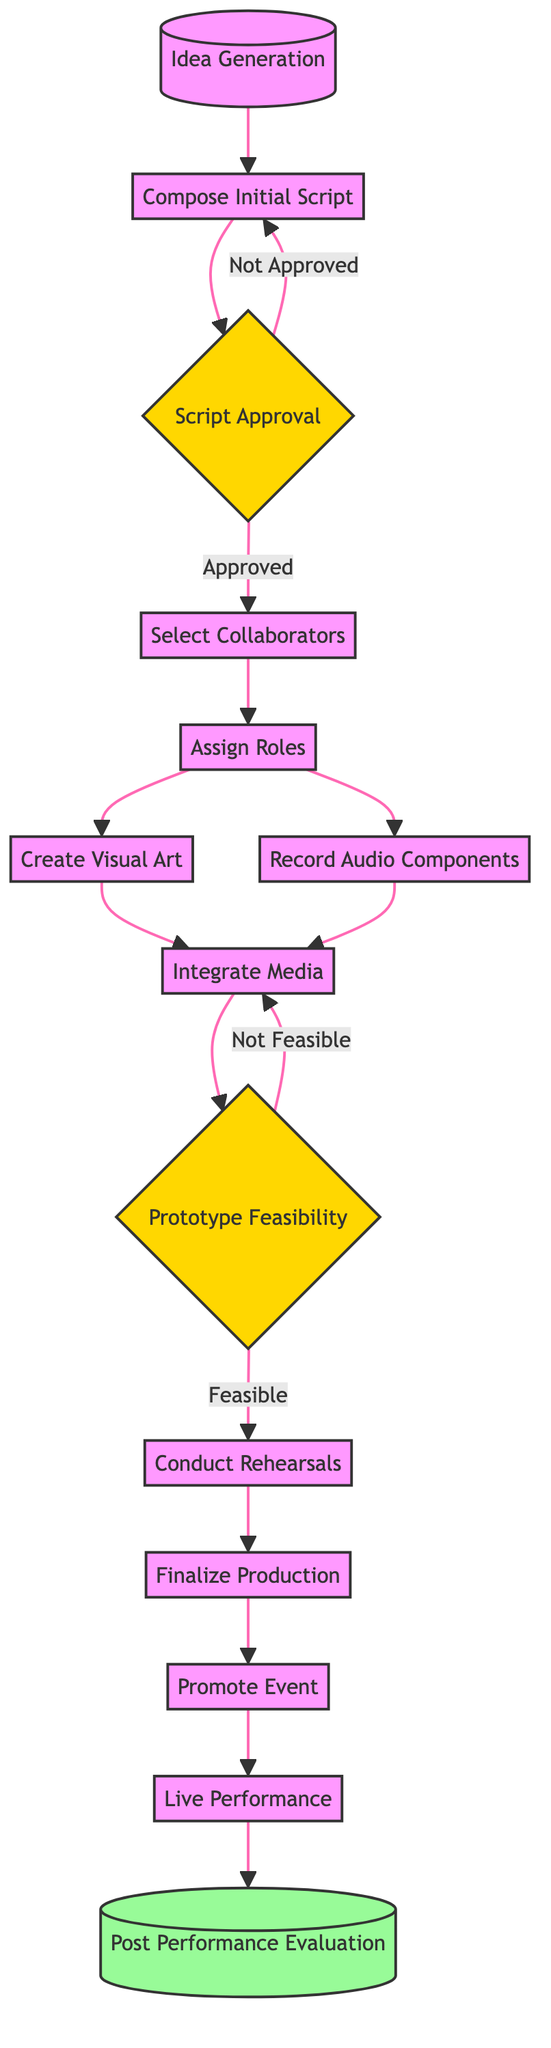What is the first activity in the diagram? The activity following the start event "IdeaGeneration" is "ComposeInitialScript." Since "IdeaGeneration" is the starting point, the next activity is clearly indicated as "ComposeInitialScript."
Answer: Compose Initial Script How many decision points are present in the diagram? There are two decision points labeled "ScriptApproval" and "PrototypeFeasibility." These decision nodes are where the flow can branch based on specific conditions.
Answer: 2 What activity follows "PromoteEvent"? The activity directly following "PromoteEvent" is "LivePerformance." This is evident as the arrow indicates flow routing from "PromoteEvent" to "LivePerformance."
Answer: Live Performance What happens if the initial script is not approved? If the initial script is not approved, the flow returns to the activity "ComposeInitialScript." This is illustrated by the arrow connecting the "Not Approved" path back to the "ComposeInitialScript" node.
Answer: Compose Initial Script Which activities require collaboration with an artist? The activities "CreateVisualArt" and "RecordAudioComponents" require collaboration with specific artists—visual and audio artists respectively, as indicated by the roles assigned during the "AssignRoles" step.
Answer: Create Visual Art, Record Audio Components What is the outcome if the prototype is deemed not feasible? If the prototype is not feasible, the flow loops back to "IntegrateMedia," allowing for further integration rather than proceeding to "ConductRehearsals." This connection is outlined in the transition labeled "Not Feasible."
Answer: Integrate Media How many activities are performed before the "LivePerformance"? There are six activities performed before reaching "LivePerformance": "ComposeInitialScript," "SelectCollaborators," "AssignRoles," "CreateVisualArt," "RecordAudioComponents," and "FinalizeProduction." Counting the activities in sequence leads us to this total.
Answer: 6 What is the last event in the diagram? The diagram concludes with the event "PostPerformanceEvaluation," which is indicated by the end event node after "LivePerformance." This node represents the final evaluation of the performance.
Answer: Post Performance Evaluation 